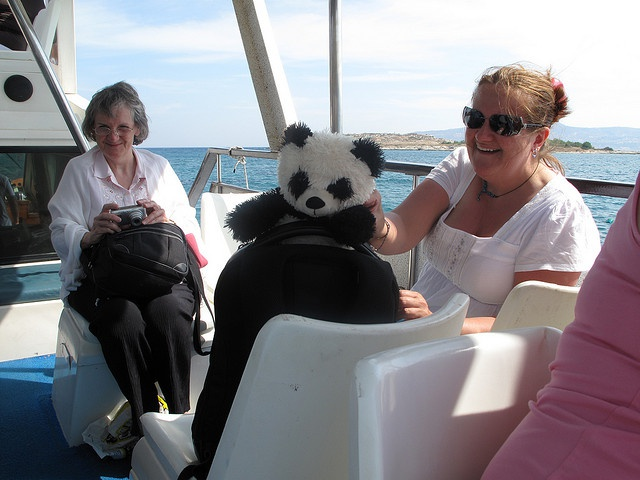Describe the objects in this image and their specific colors. I can see boat in black, white, darkgray, and gray tones, people in black, gray, white, and darkgray tones, people in black, gray, maroon, and white tones, chair in black, darkgray, gray, and lightgray tones, and people in black, purple, gray, and maroon tones in this image. 